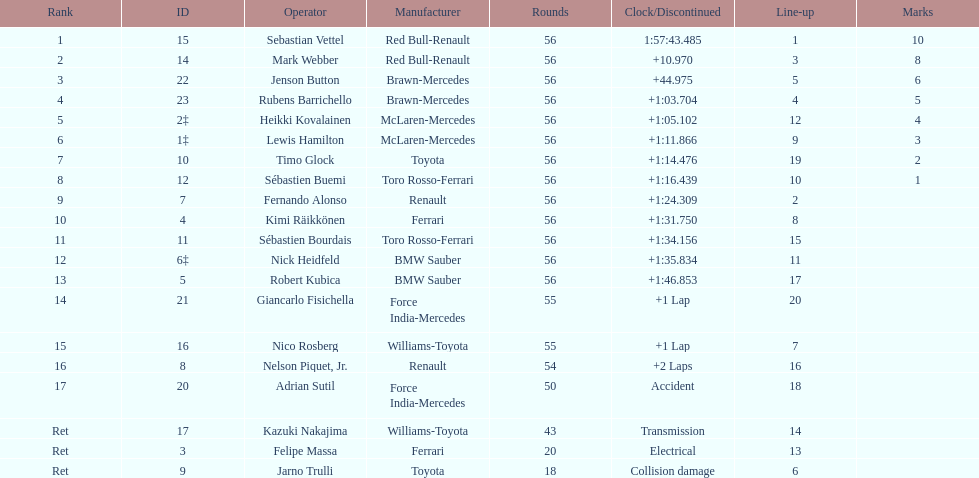What was jenson button's time? +44.975. 